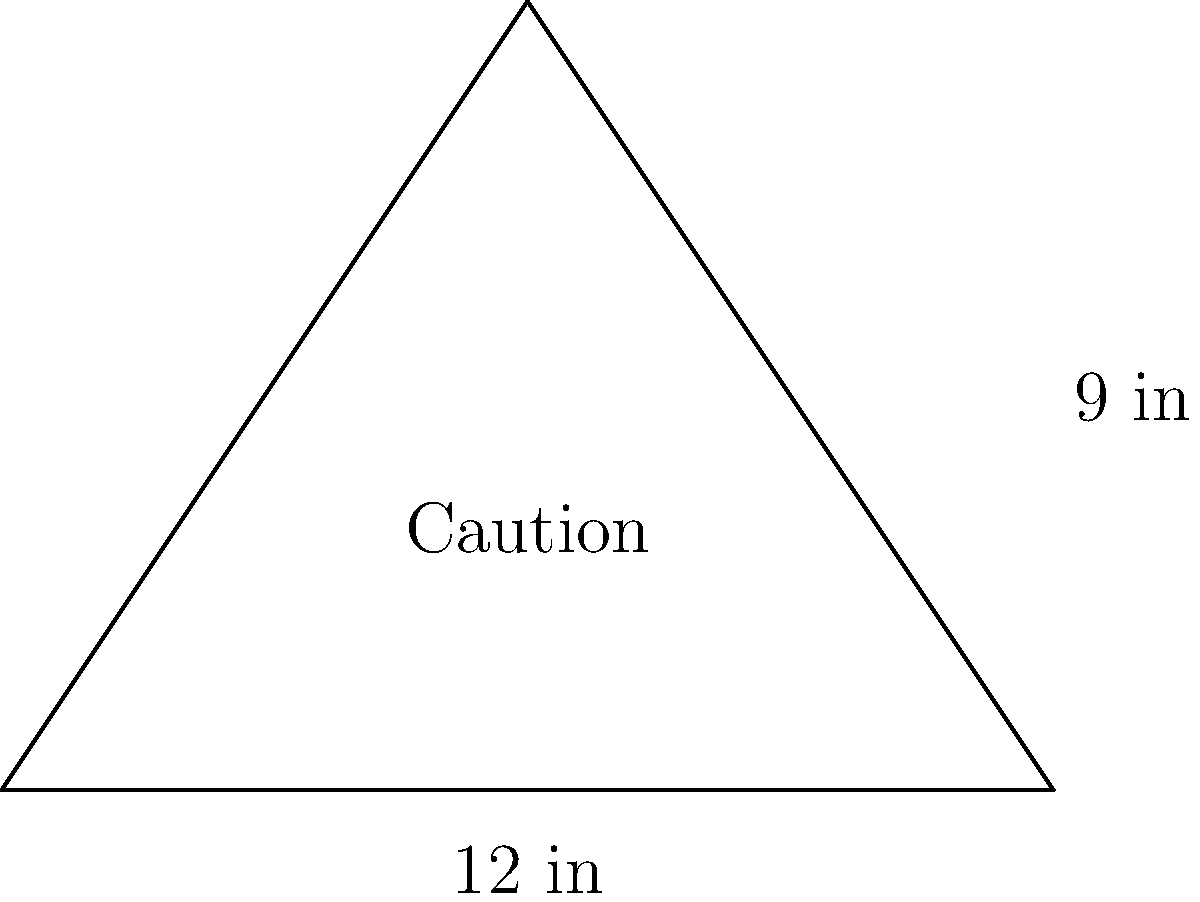As a successful entrepreneur, you're designing a triangular "Caution" sign for a new insurance startup's office. The sign has a base of 12 inches and a height of 9 inches. What is the area of this triangular sign in square inches? To calculate the area of a triangle, we use the formula:

$$A = \frac{1}{2} \times b \times h$$

Where:
$A$ = Area
$b$ = Base
$h$ = Height

Given:
Base $(b) = 12$ inches
Height $(h) = 9$ inches

Let's substitute these values into the formula:

$$A = \frac{1}{2} \times 12 \times 9$$

Now, let's solve:

$$A = \frac{1}{2} \times 108$$
$$A = 54$$

Therefore, the area of the triangular "Caution" sign is 54 square inches.

This calculation is crucial for determining material costs and ensuring the sign is appropriately sized for visibility in the office space, contributing to a safe work environment for your insurance startup.
Answer: 54 sq in 